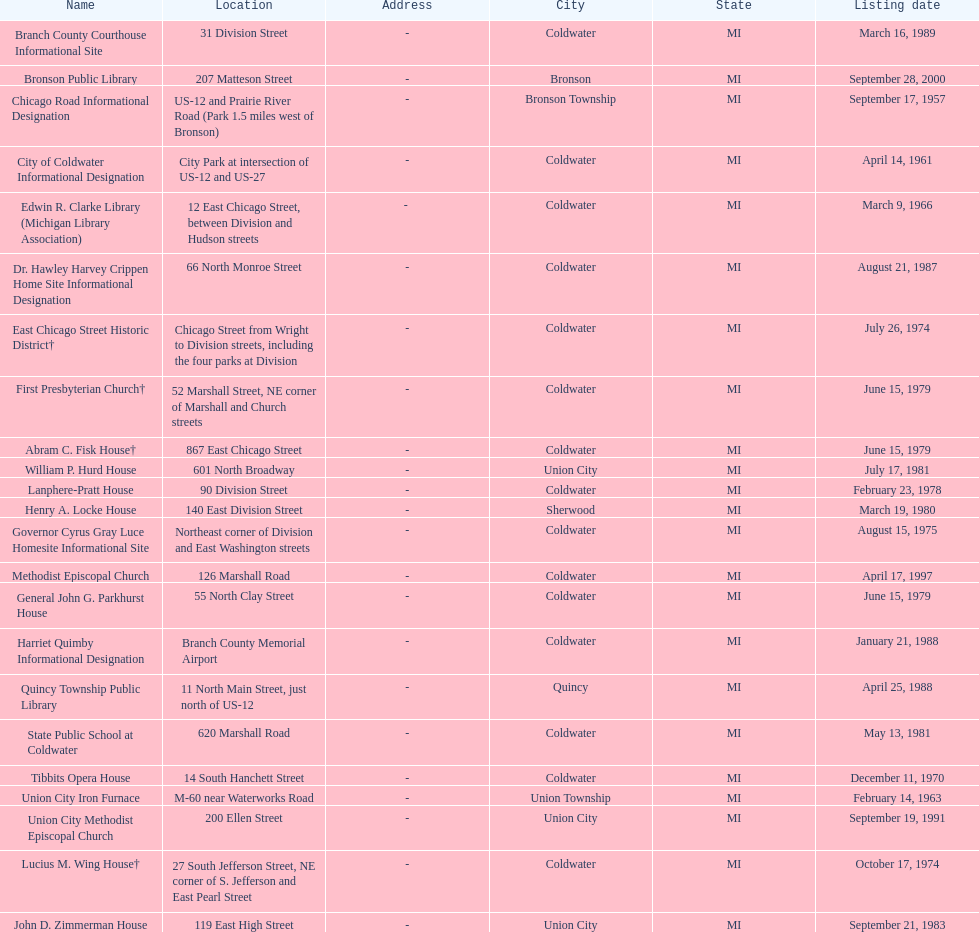Which location was mentioned first, the state public school or the edwin r. clarke library? Edwin R. Clarke Library. 